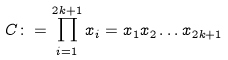Convert formula to latex. <formula><loc_0><loc_0><loc_500><loc_500>C \colon = \prod _ { i = 1 } ^ { 2 k + 1 } x _ { i } = x _ { 1 } x _ { 2 } \dots x _ { 2 k + 1 } \,</formula> 